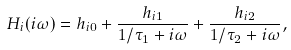<formula> <loc_0><loc_0><loc_500><loc_500>H _ { i } ( i \omega ) = h _ { i 0 } + \frac { h _ { i 1 } } { 1 / \tau _ { 1 } + i \omega } + \frac { h _ { i 2 } } { 1 / \tau _ { 2 } + i \omega } ,</formula> 